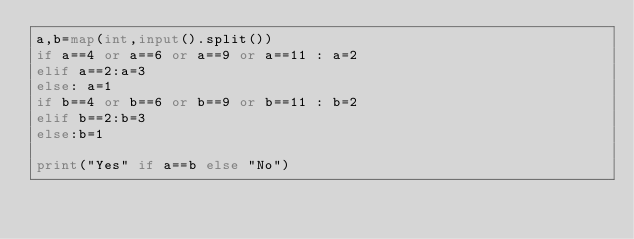Convert code to text. <code><loc_0><loc_0><loc_500><loc_500><_Python_>a,b=map(int,input().split())
if a==4 or a==6 or a==9 or a==11 : a=2
elif a==2:a=3 
else: a=1
if b==4 or b==6 or b==9 or b==11 : b=2
elif b==2:b=3 
else:b=1

print("Yes" if a==b else "No")</code> 